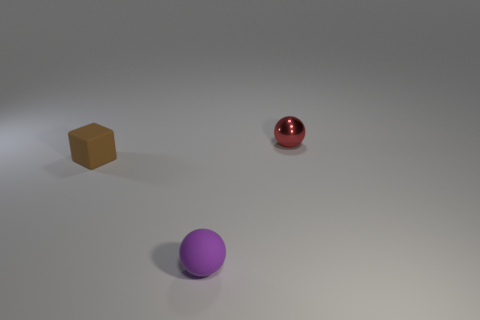Add 2 red matte cubes. How many objects exist? 5 Subtract all blocks. How many objects are left? 2 Subtract all tiny things. Subtract all big red matte blocks. How many objects are left? 0 Add 2 tiny blocks. How many tiny blocks are left? 3 Add 3 gray blocks. How many gray blocks exist? 3 Subtract 0 blue spheres. How many objects are left? 3 